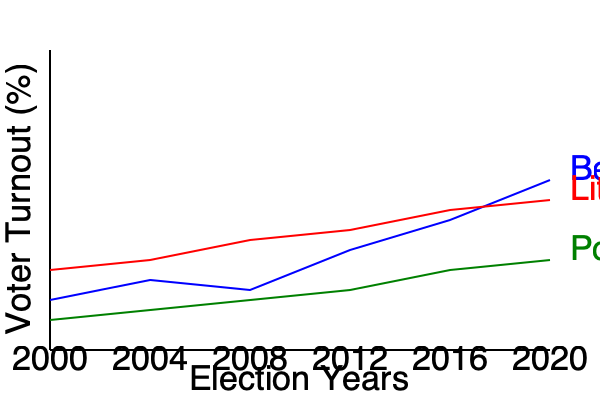Based on the line graph showing voter turnout trends in Belarus, Lithuania, and Poland from 2000 to 2020, which country experienced the most significant decline in voter turnout over the entire period, and what factors might explain this trend in the context of Eastern European politics? To answer this question, we need to analyze the trends for each country:

1. Belarus (blue line):
   - Started at around 70% in 2000
   - Ended at around 82% in 2020
   - Overall trend: Increasing

2. Lithuania (red line):
   - Started at around 73% in 2000
   - Ended at around 75% in 2020
   - Overall trend: Slight increase

3. Poland (green line):
   - Started at around 65% in 2000
   - Ended at around 68% in 2020
   - Overall trend: Slight increase

None of the countries show a significant decline in voter turnout. However, Belarus shows the most dramatic change, with a notable increase in voter turnout.

Factors that might explain the trends in Eastern European politics:

1. Belarus:
   - Increased authoritarian control under Lukashenko's regime
   - Allegations of voter intimidation and electoral fraud
   - State-controlled media influencing public opinion
   - Mandatory voting practices in some elections

2. Lithuania and Poland:
   - Relatively stable democracies with EU membership
   - More transparent electoral processes
   - Diverse political landscapes with multiple parties
   - Increased political awareness and civic engagement

The question itself contains a misconception, as none of the countries show a significant decline in voter turnout. Instead, Belarus shows a notable increase, which could be attributed to the factors mentioned above, particularly the authoritarian nature of its political system.
Answer: None; Belarus shows the most change with a significant increase, likely due to authoritarian practices. 